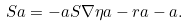Convert formula to latex. <formula><loc_0><loc_0><loc_500><loc_500>S a = - a S \nabla \eta a - r a - a .</formula> 